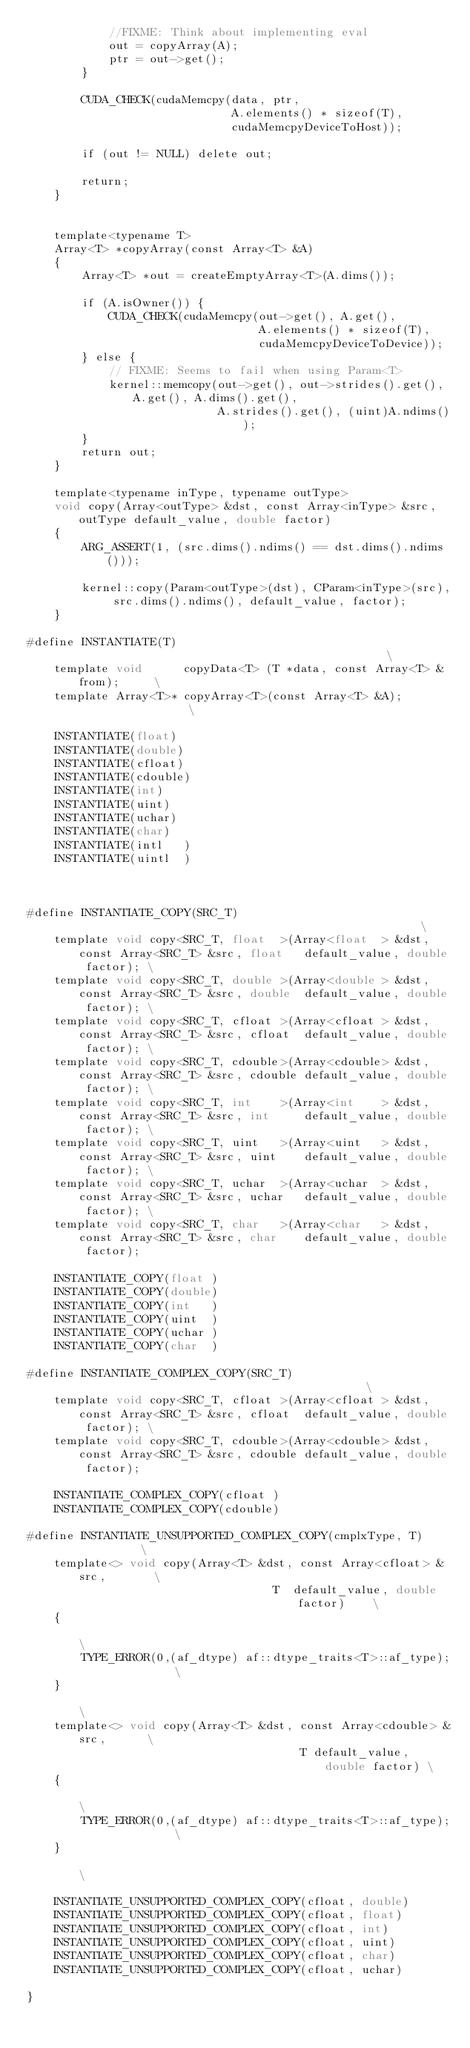<code> <loc_0><loc_0><loc_500><loc_500><_Cuda_>            //FIXME: Think about implementing eval
            out = copyArray(A);
            ptr = out->get();
        }

        CUDA_CHECK(cudaMemcpy(data, ptr,
                              A.elements() * sizeof(T),
                              cudaMemcpyDeviceToHost));

        if (out != NULL) delete out;

        return;
    }


    template<typename T>
    Array<T> *copyArray(const Array<T> &A)
    {
        Array<T> *out = createEmptyArray<T>(A.dims());

        if (A.isOwner()) {
            CUDA_CHECK(cudaMemcpy(out->get(), A.get(),
                                  A.elements() * sizeof(T),
                                  cudaMemcpyDeviceToDevice));
        } else {
            // FIXME: Seems to fail when using Param<T>
            kernel::memcopy(out->get(), out->strides().get(), A.get(), A.dims().get(),
                            A.strides().get(), (uint)A.ndims());
        }
        return out;
    }

    template<typename inType, typename outType>
    void copy(Array<outType> &dst, const Array<inType> &src, outType default_value, double factor)
    {
        ARG_ASSERT(1, (src.dims().ndims() == dst.dims().ndims()));

        kernel::copy(Param<outType>(dst), CParam<inType>(src), src.dims().ndims(), default_value, factor);
    }

#define INSTANTIATE(T)                                                  \
    template void      copyData<T> (T *data, const Array<T> &from);     \
    template Array<T>* copyArray<T>(const Array<T> &A);                 \

    INSTANTIATE(float)
    INSTANTIATE(double)
    INSTANTIATE(cfloat)
    INSTANTIATE(cdouble)
    INSTANTIATE(int)
    INSTANTIATE(uint)
    INSTANTIATE(uchar)
    INSTANTIATE(char)
    INSTANTIATE(intl   )
    INSTANTIATE(uintl  )



#define INSTANTIATE_COPY(SRC_T)                                                       \
    template void copy<SRC_T, float  >(Array<float  > &dst, const Array<SRC_T> &src, float   default_value, double factor); \
    template void copy<SRC_T, double >(Array<double > &dst, const Array<SRC_T> &src, double  default_value, double factor); \
    template void copy<SRC_T, cfloat >(Array<cfloat > &dst, const Array<SRC_T> &src, cfloat  default_value, double factor); \
    template void copy<SRC_T, cdouble>(Array<cdouble> &dst, const Array<SRC_T> &src, cdouble default_value, double factor); \
    template void copy<SRC_T, int    >(Array<int    > &dst, const Array<SRC_T> &src, int     default_value, double factor); \
    template void copy<SRC_T, uint   >(Array<uint   > &dst, const Array<SRC_T> &src, uint    default_value, double factor); \
    template void copy<SRC_T, uchar  >(Array<uchar  > &dst, const Array<SRC_T> &src, uchar   default_value, double factor); \
    template void copy<SRC_T, char   >(Array<char   > &dst, const Array<SRC_T> &src, char    default_value, double factor);

    INSTANTIATE_COPY(float )
    INSTANTIATE_COPY(double)
    INSTANTIATE_COPY(int   )
    INSTANTIATE_COPY(uint  )
    INSTANTIATE_COPY(uchar )
    INSTANTIATE_COPY(char  )

#define INSTANTIATE_COMPLEX_COPY(SRC_T)                                               \
    template void copy<SRC_T, cfloat >(Array<cfloat > &dst, const Array<SRC_T> &src, cfloat  default_value, double factor); \
    template void copy<SRC_T, cdouble>(Array<cdouble> &dst, const Array<SRC_T> &src, cdouble default_value, double factor);

    INSTANTIATE_COMPLEX_COPY(cfloat )
    INSTANTIATE_COMPLEX_COPY(cdouble)

#define INSTANTIATE_UNSUPPORTED_COMPLEX_COPY(cmplxType, T)              \
    template<> void copy(Array<T> &dst, const Array<cfloat> &src,       \
                                    T  default_value, double factor)    \
    {                                                                   \
        TYPE_ERROR(0,(af_dtype) af::dtype_traits<T>::af_type);          \
    }                                                                   \
    template<> void copy(Array<T> &dst, const Array<cdouble> &src,      \
                                        T default_value, double factor) \
    {                                                                   \
        TYPE_ERROR(0,(af_dtype) af::dtype_traits<T>::af_type);          \
    }                                                                   \

    INSTANTIATE_UNSUPPORTED_COMPLEX_COPY(cfloat, double)
    INSTANTIATE_UNSUPPORTED_COMPLEX_COPY(cfloat, float)
    INSTANTIATE_UNSUPPORTED_COMPLEX_COPY(cfloat, int)
    INSTANTIATE_UNSUPPORTED_COMPLEX_COPY(cfloat, uint)
    INSTANTIATE_UNSUPPORTED_COMPLEX_COPY(cfloat, char)
    INSTANTIATE_UNSUPPORTED_COMPLEX_COPY(cfloat, uchar)

}
</code> 